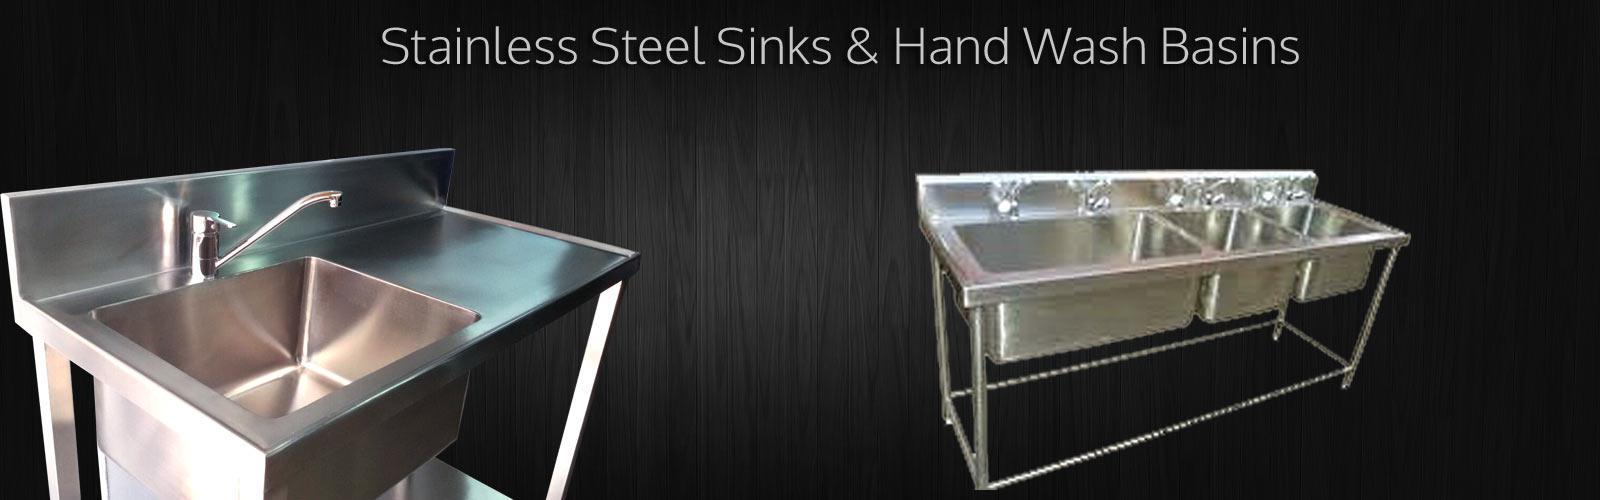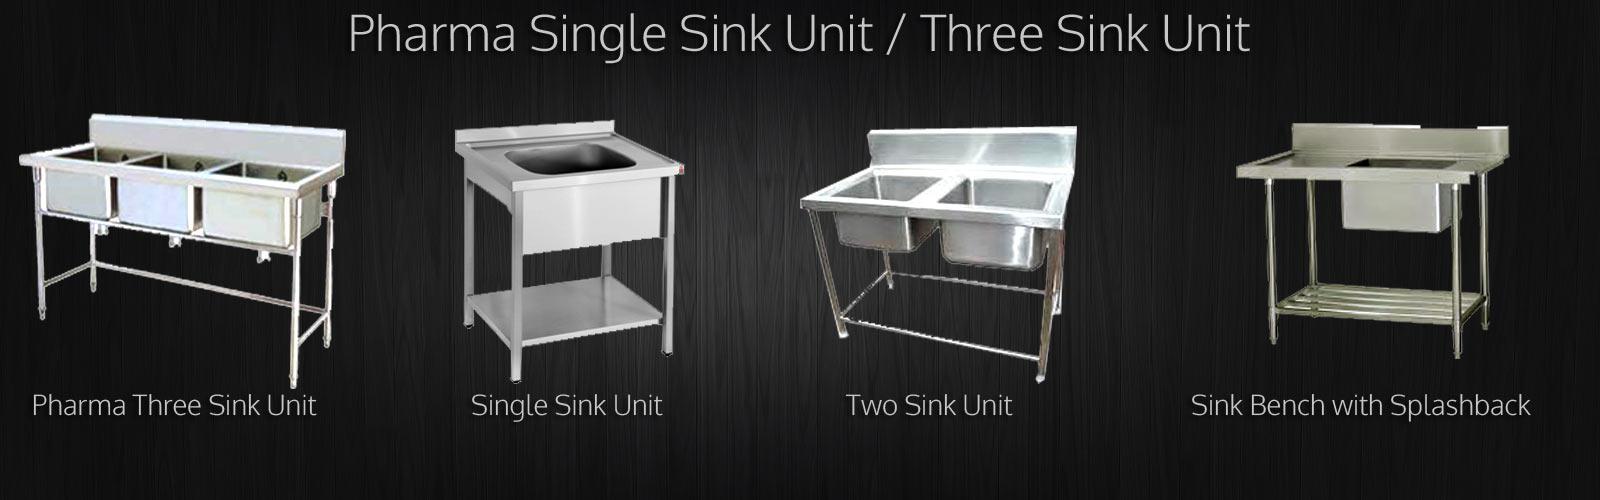The first image is the image on the left, the second image is the image on the right. Examine the images to the left and right. Is the description "There is exactly one faucet in the left image." accurate? Answer yes or no. No. The first image is the image on the left, the second image is the image on the right. For the images shown, is this caption "Each image shows a steel sink with an undivided rectangular basin, but the sink on the right has a longer 'bin' under it." true? Answer yes or no. No. 